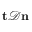Convert formula to latex. <formula><loc_0><loc_0><loc_500><loc_500>t \mathcal { D } n</formula> 